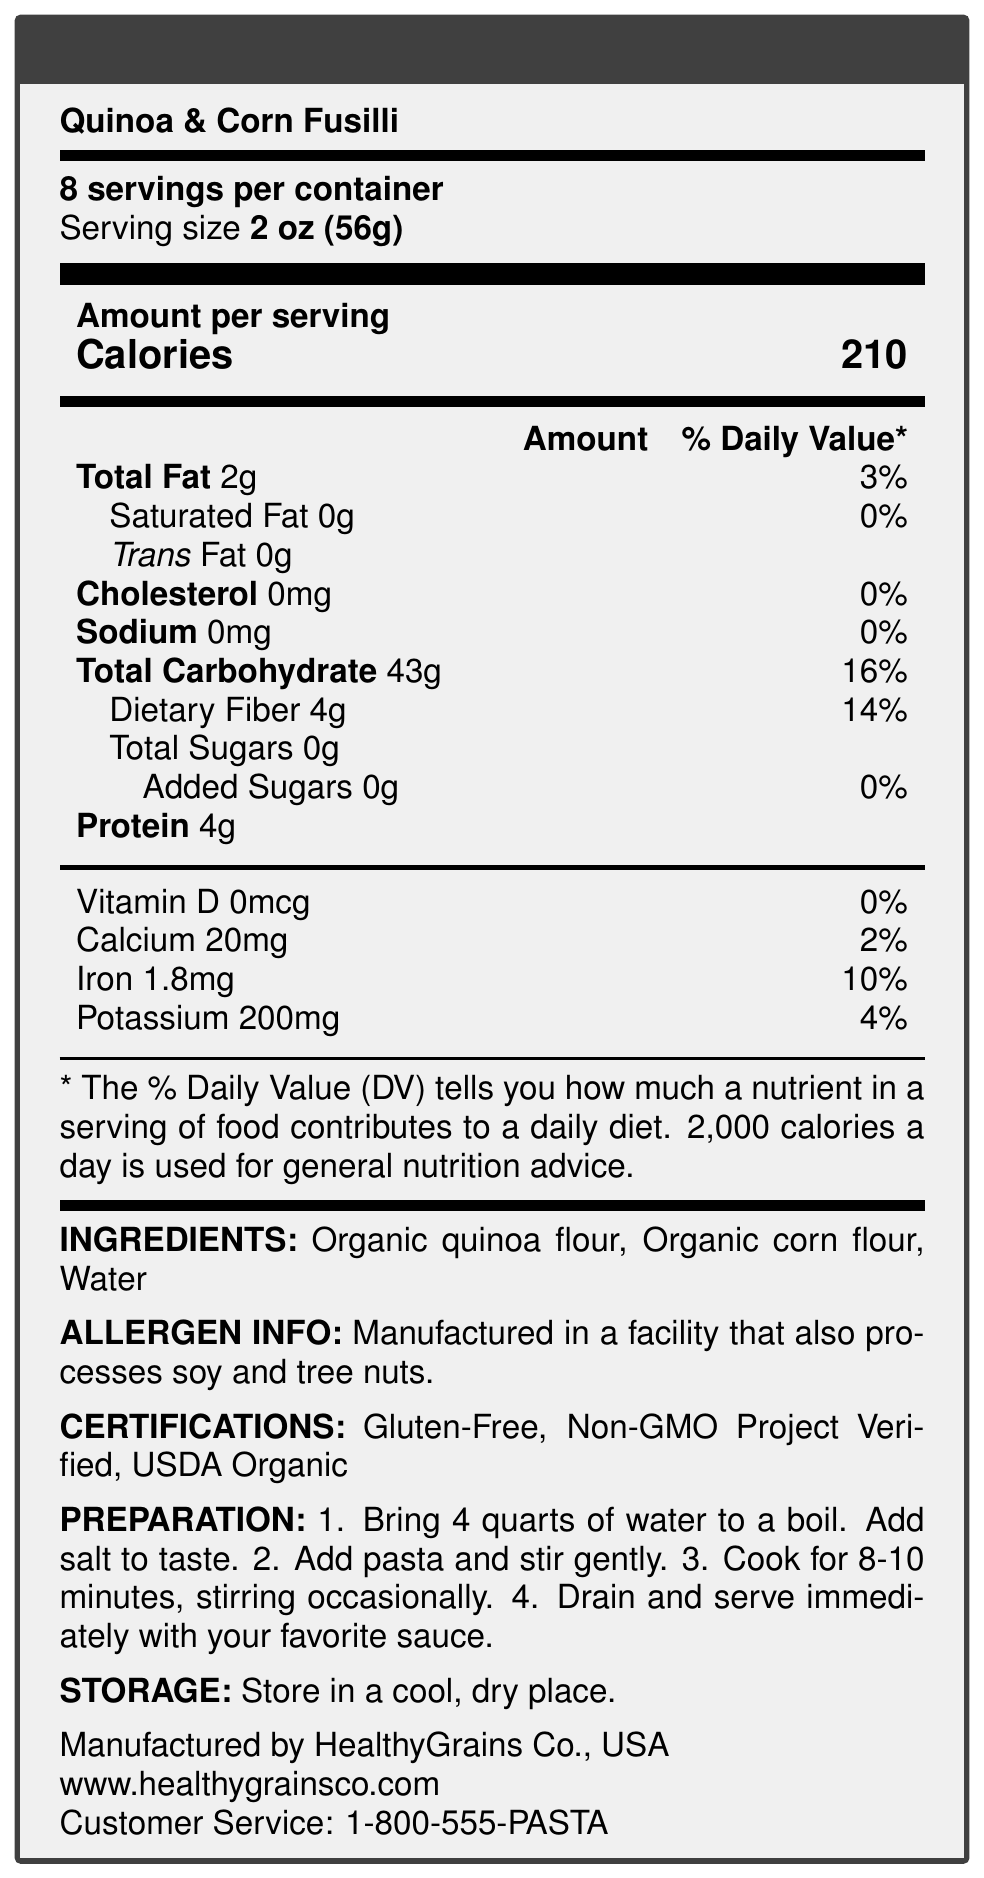What is the percentage of daily value for dietary fiber per serving? The document states that the dietary fiber content per serving is 4g, which is 14% of the daily value.
Answer: 14% How many calories are there per serving of Quinoa & Corn Fusilli? According to the document, each serving of the pasta contains 210 calories.
Answer: 210 What allergens are mentioned in the document? The allergen info section specifies that the product is manufactured in a facility that also processes soy and tree nuts.
Answer: Soy and tree nuts How much iron is in one serving? The nutrition facts indicate that there is 1.8mg of iron per serving, which is 10% of the daily value.
Answer: 1.8mg What are the main ingredients of the Quinoa & Corn Fusilli? The ingredients listed are organic quinoa flour, organic corn flour, and water.
Answer: Organic quinoa flour, Organic corn flour, Water Are there any added sugars in the product? (Yes/No) The document notes that there are 0g of added sugars, corresponding to 0% of the daily value.
Answer: No Which one of the following is NOT listed as a certification for this product? A. Gluten-Free B. Vegan C. USDA Organic D. Non-GMO Project Verified The product is certified as Gluten-Free, Non-GMO Project Verified, and USDA Organic, but Vegan is not listed as a certification.
Answer: B How should the product be stored? The storage instructions specify storing the product in a cool, dry place.
Answer: In a cool, dry place How long should you cook the pasta according to the preparation instructions? A. 4-6 minutes B. 6-8 minutes C. 8-10 minutes D. 10-12 minutes The preparation instructions state to cook the pasta for 8-10 minutes.
Answer: C Summarize the main purpose of the document. This summary includes all the key elements such as nutritional content, preparation and storage guidelines, ingredient and allergen information, and manufacturer details.
Answer: The document provides nutrition facts and additional product information for Quinoa & Corn Fusilli, including serving size, calories per serving, nutrient content, ingredient list, allergen information, certifications, preparation instructions, storage instructions, and manufacturer details. What is the contact phone number for customer service? The document lists the customer service phone number as 1-800-555-PASTA at the bottom.
Answer: 1-800-555-PASTA Where is the product manufactured? The document mentions that the product is manufactured by HealthyGrains Co. in the USA.
Answer: USA What other grains are used in the pasta besides quinoa? The ingredients section lists organic corn flour along with organic quinoa flour and water.
Answer: Corn Does the product contain any cholesterol? The document specifies that the product contains 0mg of cholesterol, which is 0% of the daily value.
Answer: No What certifications does the product have? The certifications listed are Gluten-Free, Non-GMO Project Verified, and USDA Organic.
Answer: Gluten-Free, Non-GMO Project Verified, USDA Organic What is the country of origin for the product? The document states that the product is made in the USA.
Answer: USA What are the dietary fiber and protein contents per serving respectively? The dietary fiber content per serving is 4g, and the protein content per serving is also 4g as listed in the nutritional information.
Answer: 4g, 4g How many servings are there per container? The document mentions that there are 8 servings per container.
Answer: 8 What is the source of the calories in Quinoa & Corn Fusilli? The document specifies the total calorie count but does not break down the sources of calories (fat, protein, carbohydrates).
Answer: Cannot be determined 